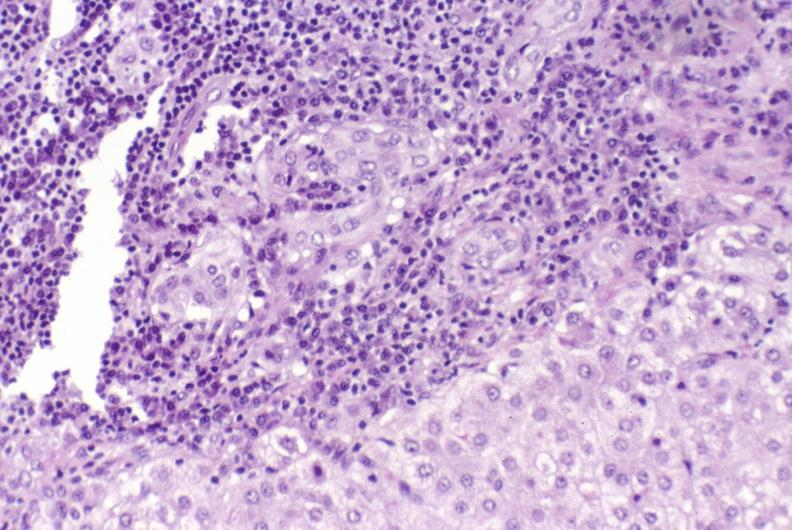s liver present?
Answer the question using a single word or phrase. Yes 